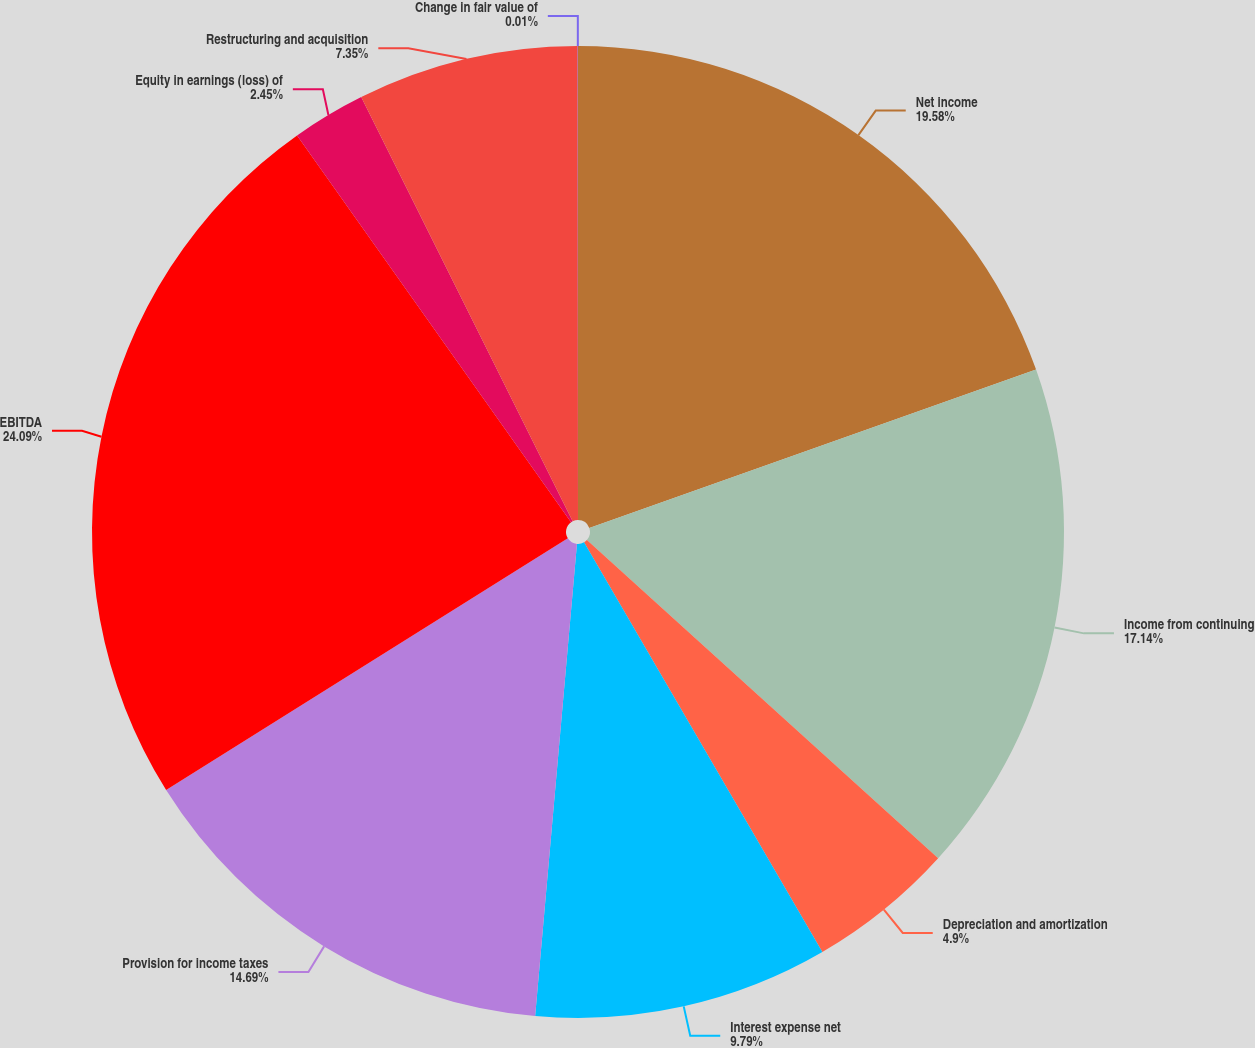Convert chart to OTSL. <chart><loc_0><loc_0><loc_500><loc_500><pie_chart><fcel>Net income<fcel>Income from continuing<fcel>Depreciation and amortization<fcel>Interest expense net<fcel>Provision for income taxes<fcel>EBITDA<fcel>Equity in earnings (loss) of<fcel>Restructuring and acquisition<fcel>Change in fair value of<nl><fcel>19.58%<fcel>17.14%<fcel>4.9%<fcel>9.79%<fcel>14.69%<fcel>24.1%<fcel>2.45%<fcel>7.35%<fcel>0.01%<nl></chart> 